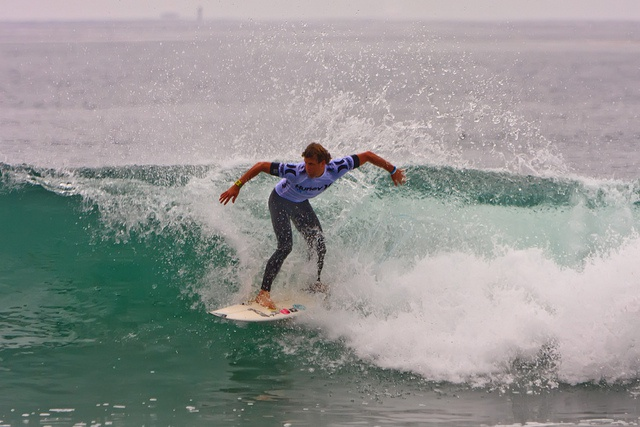Describe the objects in this image and their specific colors. I can see people in lightgray, black, gray, maroon, and darkgray tones and surfboard in lightgray, darkgray, gray, and tan tones in this image. 